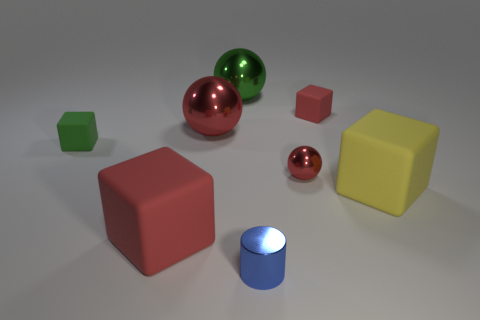There is a small ball; does it have the same color as the large matte thing to the left of the metal cylinder?
Ensure brevity in your answer.  Yes. Do the rubber block that is in front of the yellow rubber cube and the small metal sphere have the same color?
Provide a succinct answer. Yes. What number of things are either tiny metallic spheres or red cubes on the right side of the green metal ball?
Ensure brevity in your answer.  2. What is the thing that is both to the right of the big green shiny object and in front of the large yellow cube made of?
Make the answer very short. Metal. What is the material of the tiny block behind the green rubber block?
Make the answer very short. Rubber. What color is the other tiny cube that is made of the same material as the small green cube?
Offer a very short reply. Red. Is the shape of the large red rubber object the same as the tiny thing that is on the left side of the metallic cylinder?
Provide a short and direct response. Yes. There is a cylinder; are there any objects right of it?
Give a very brief answer. Yes. There is another sphere that is the same color as the tiny metallic ball; what is it made of?
Make the answer very short. Metal. Does the green matte block have the same size as the red matte object behind the large yellow cube?
Keep it short and to the point. Yes. 